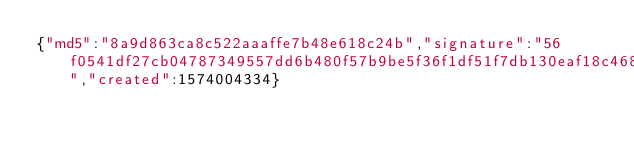Convert code to text. <code><loc_0><loc_0><loc_500><loc_500><_SML_>{"md5":"8a9d863ca8c522aaaffe7b48e618c24b","signature":"56f0541df27cb04787349557dd6b480f57b9be5f36f1df51f7db130eaf18c468e5c65cf02bf0bc77d00042cdeb5b7342a2b0f8ccfc1a0314b22e759e45ba490e","created":1574004334}</code> 